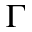<formula> <loc_0><loc_0><loc_500><loc_500>\Gamma</formula> 